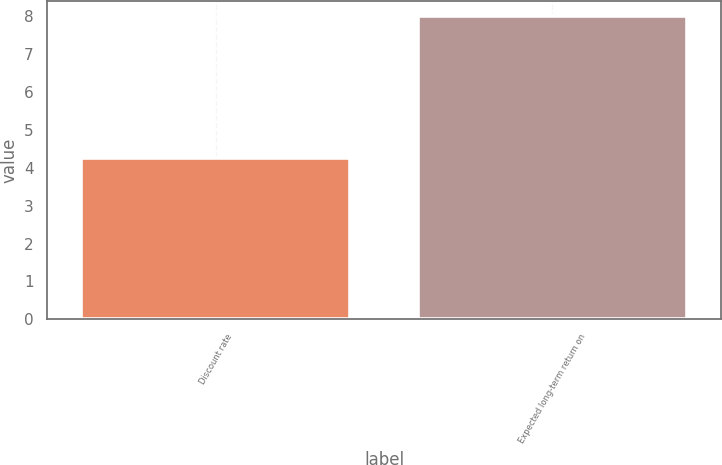Convert chart to OTSL. <chart><loc_0><loc_0><loc_500><loc_500><bar_chart><fcel>Discount rate<fcel>Expected long-term return on<nl><fcel>4.25<fcel>8<nl></chart> 